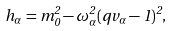Convert formula to latex. <formula><loc_0><loc_0><loc_500><loc_500>h _ { \alpha } = m _ { 0 } ^ { 2 } - \omega _ { \alpha } ^ { 2 } ( q v _ { \alpha } - 1 ) ^ { 2 } ,</formula> 